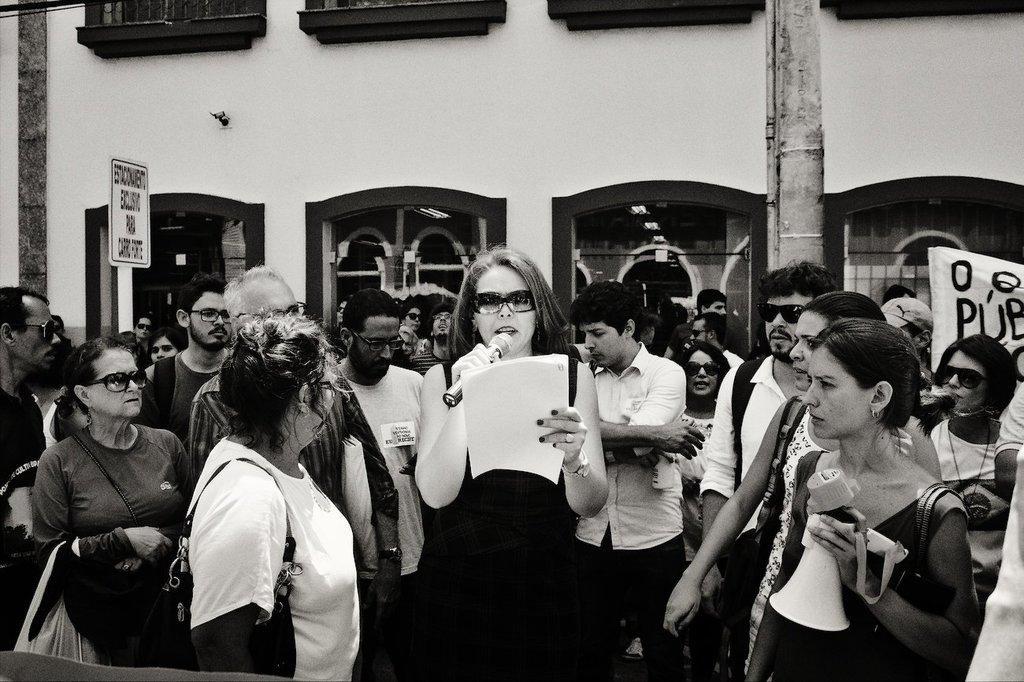Can you describe this image briefly? In the image there are many people. There are few people with goggles, bags and some other things. On the right side of the image there is a banner with some text on it. And also there is a sign board and a pole. In the background there is a wall with glass windows. There is a lady holding a megaphone in her hand. 